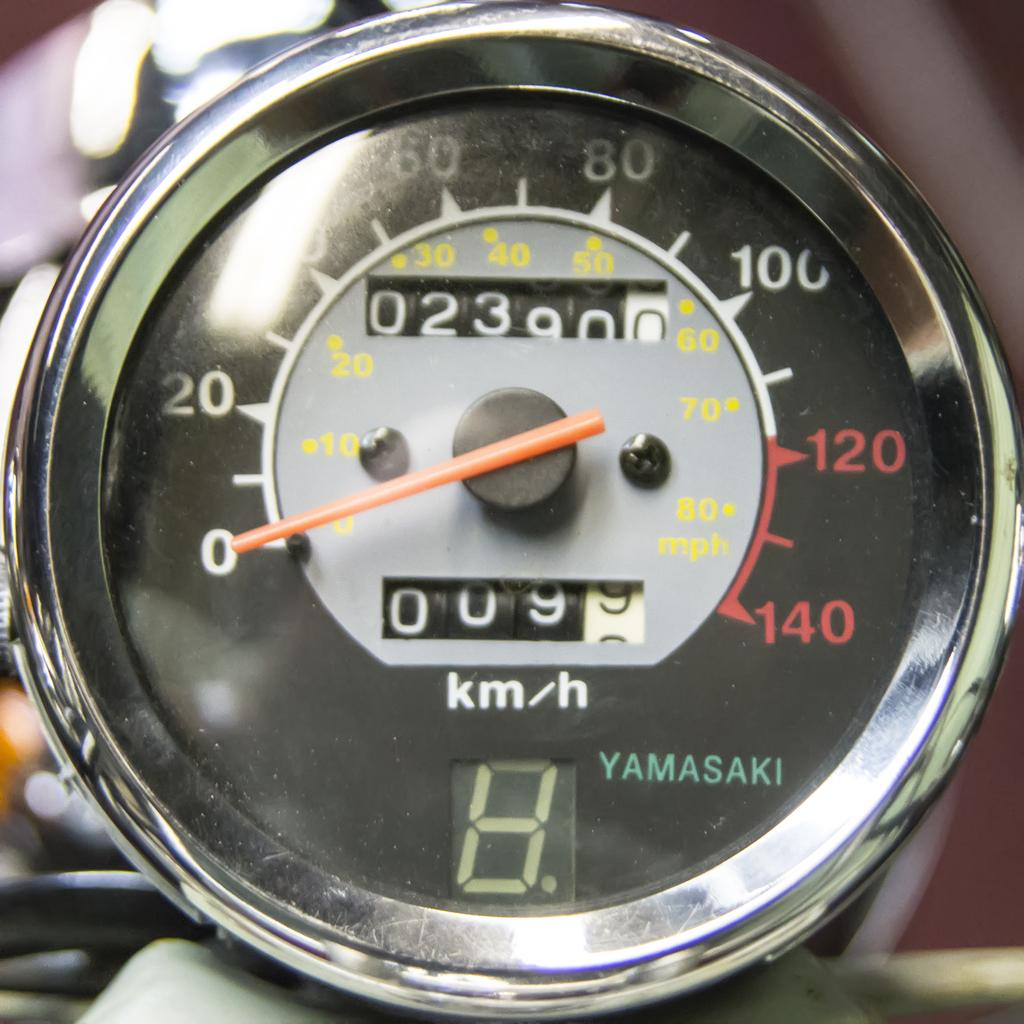Provide a one-sentence caption for the provided image. A Yamasaki motorcycle tachometer with 2390 miles listed. 